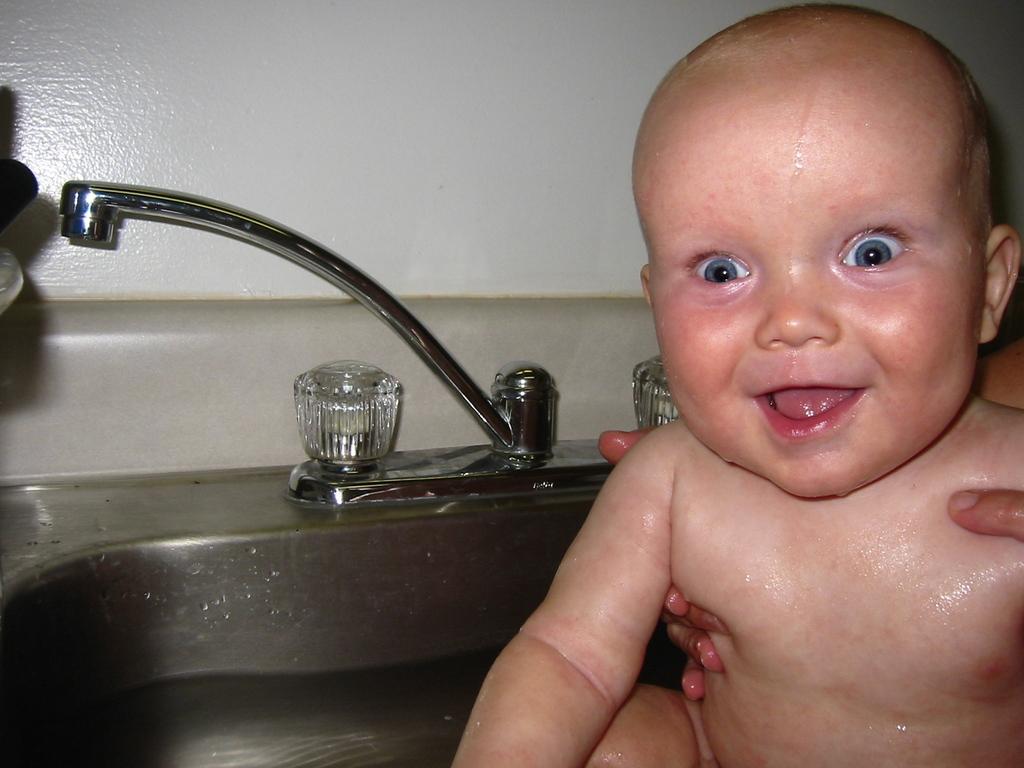What is the person's hand doing in the image? The person's hand is holding a baby in the image. Where is the baby located in the image? The baby is in the water. What can be seen near the water in the image? There is a tap visible in the image. What is behind the baby in the image? There is a wall behind the baby. What advice does the friend give to the person holding the baby in the image? There is no friend present in the image, and therefore no advice can be given. What type of whip is being used to entertain the baby in the image? There is no whip present in the image, and the baby is not being entertained with any such object. 